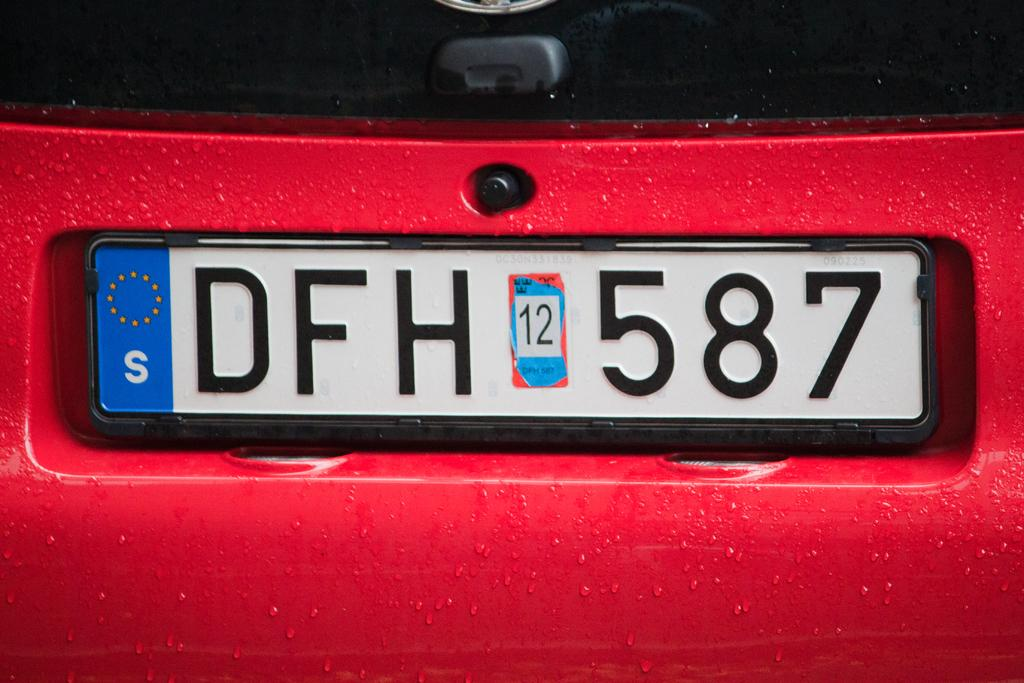<image>
Give a short and clear explanation of the subsequent image. A red car with a tag that reads DFH 587. 